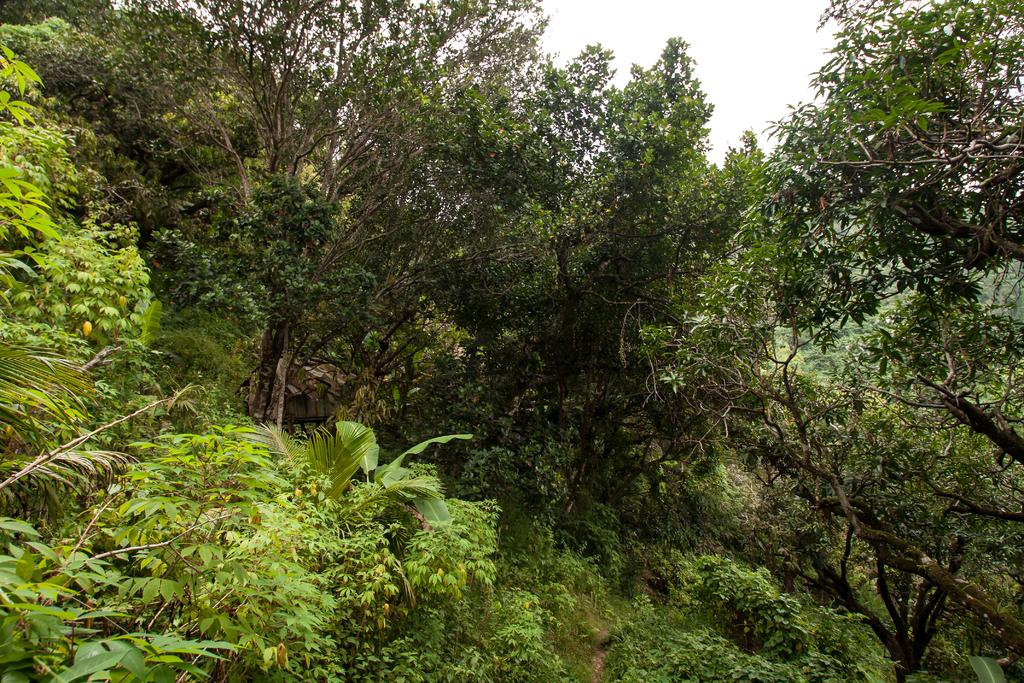What is the primary feature of the landscape in the image? There are many trees in the image. What type of structure can be seen in the image? There is a house in the image. What time is depicted in the image? The time of day is not visible or indicated in the image. What type of plants are growing on the plate in the image? There is no plate present in the image, and therefore no plants growing on it. 